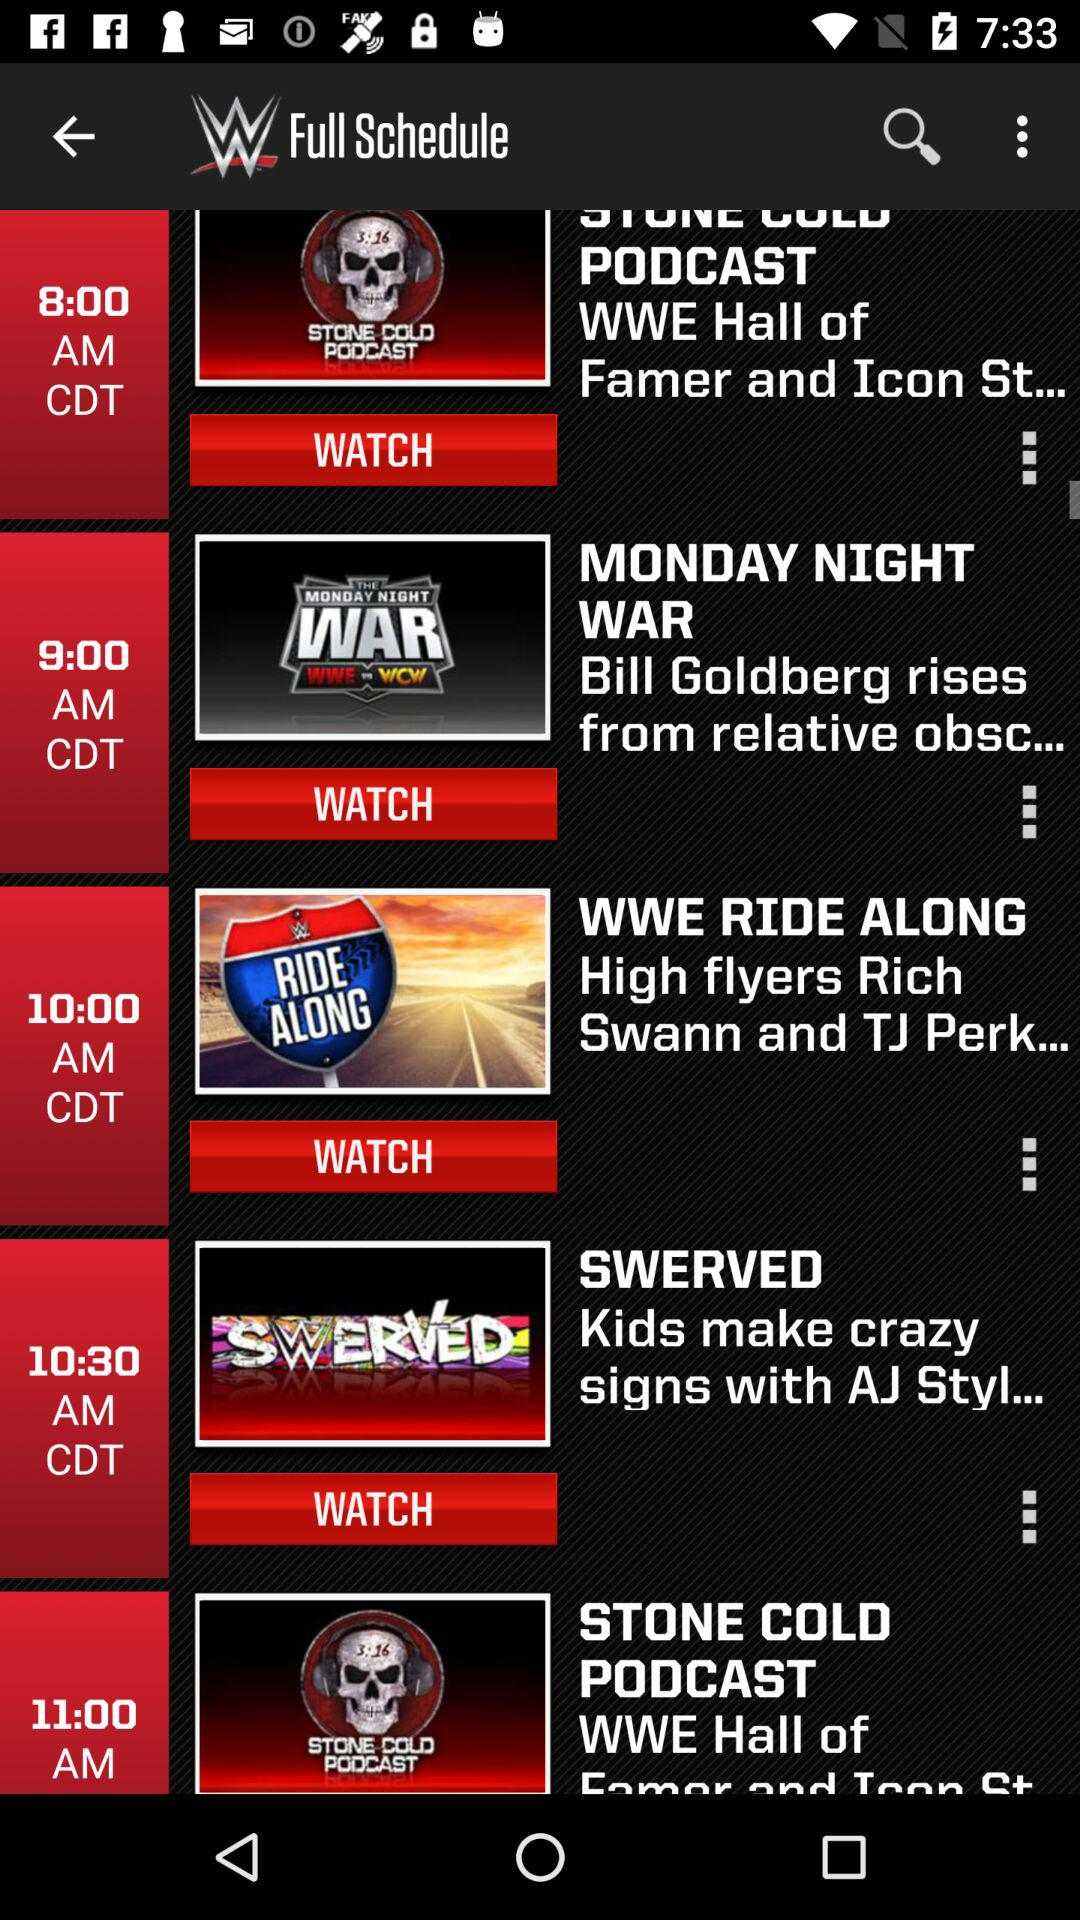What is the time of "WWE Ride Along"? The time is 10:00 AM CDT. 